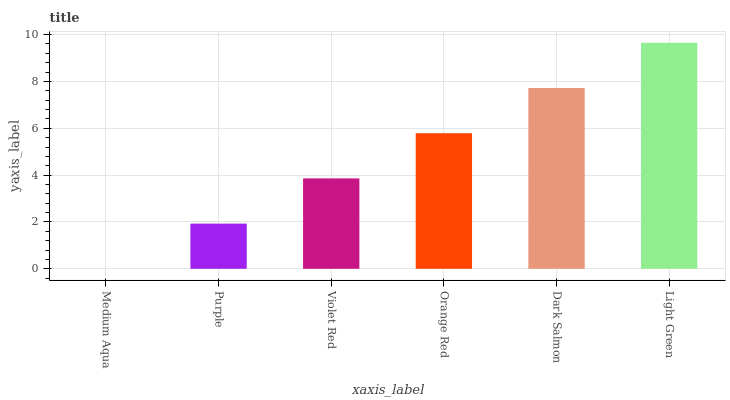Is Medium Aqua the minimum?
Answer yes or no. Yes. Is Light Green the maximum?
Answer yes or no. Yes. Is Purple the minimum?
Answer yes or no. No. Is Purple the maximum?
Answer yes or no. No. Is Purple greater than Medium Aqua?
Answer yes or no. Yes. Is Medium Aqua less than Purple?
Answer yes or no. Yes. Is Medium Aqua greater than Purple?
Answer yes or no. No. Is Purple less than Medium Aqua?
Answer yes or no. No. Is Orange Red the high median?
Answer yes or no. Yes. Is Violet Red the low median?
Answer yes or no. Yes. Is Purple the high median?
Answer yes or no. No. Is Light Green the low median?
Answer yes or no. No. 